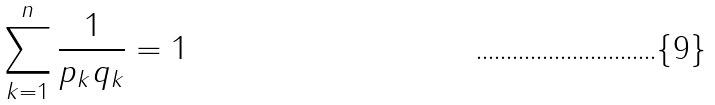<formula> <loc_0><loc_0><loc_500><loc_500>\sum _ { k = 1 } ^ { n } \frac { 1 } { p _ { k } q _ { k } } = 1</formula> 